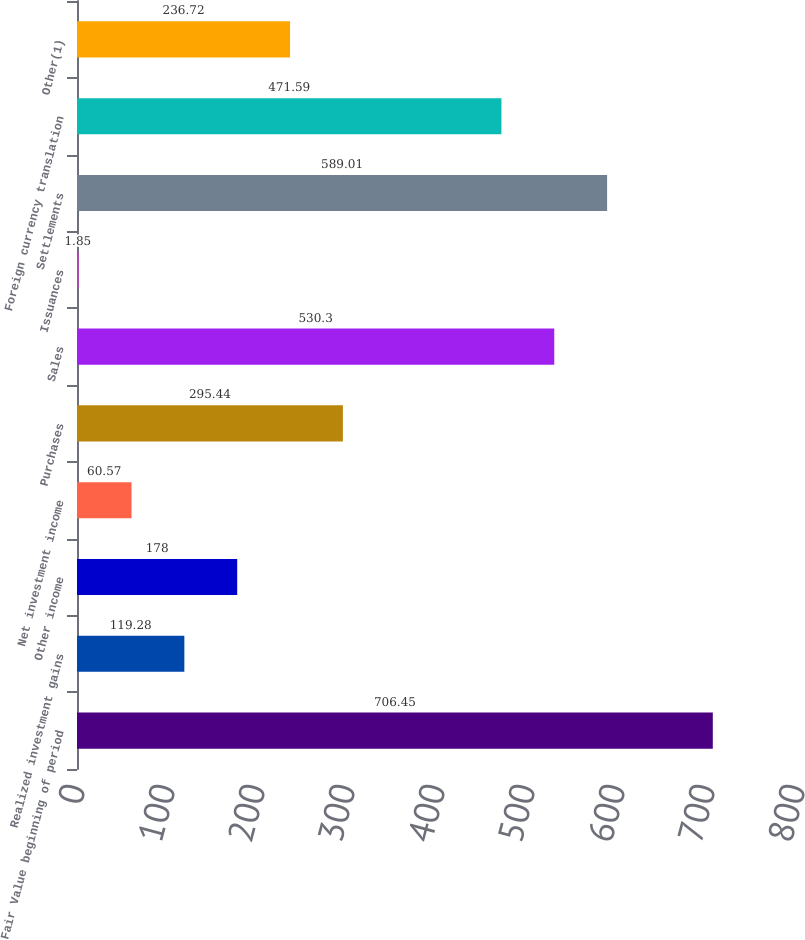Convert chart to OTSL. <chart><loc_0><loc_0><loc_500><loc_500><bar_chart><fcel>Fair Value beginning of period<fcel>Realized investment gains<fcel>Other income<fcel>Net investment income<fcel>Purchases<fcel>Sales<fcel>Issuances<fcel>Settlements<fcel>Foreign currency translation<fcel>Other(1)<nl><fcel>706.45<fcel>119.28<fcel>178<fcel>60.57<fcel>295.44<fcel>530.3<fcel>1.85<fcel>589.01<fcel>471.59<fcel>236.72<nl></chart> 